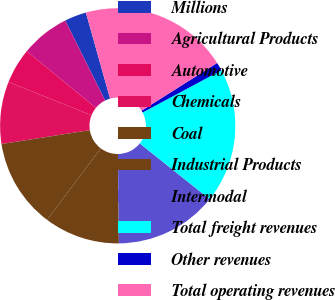Convert chart. <chart><loc_0><loc_0><loc_500><loc_500><pie_chart><fcel>Millions<fcel>Agricultural Products<fcel>Automotive<fcel>Chemicals<fcel>Coal<fcel>Industrial Products<fcel>Intermodal<fcel>Total freight revenues<fcel>Other revenues<fcel>Total operating revenues<nl><fcel>3.0%<fcel>6.71%<fcel>4.85%<fcel>8.56%<fcel>12.27%<fcel>10.41%<fcel>14.12%<fcel>18.54%<fcel>1.15%<fcel>20.39%<nl></chart> 